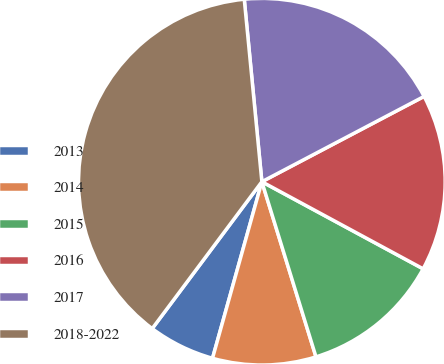<chart> <loc_0><loc_0><loc_500><loc_500><pie_chart><fcel>2013<fcel>2014<fcel>2015<fcel>2016<fcel>2017<fcel>2018-2022<nl><fcel>5.87%<fcel>9.11%<fcel>12.35%<fcel>15.59%<fcel>18.83%<fcel>38.27%<nl></chart> 